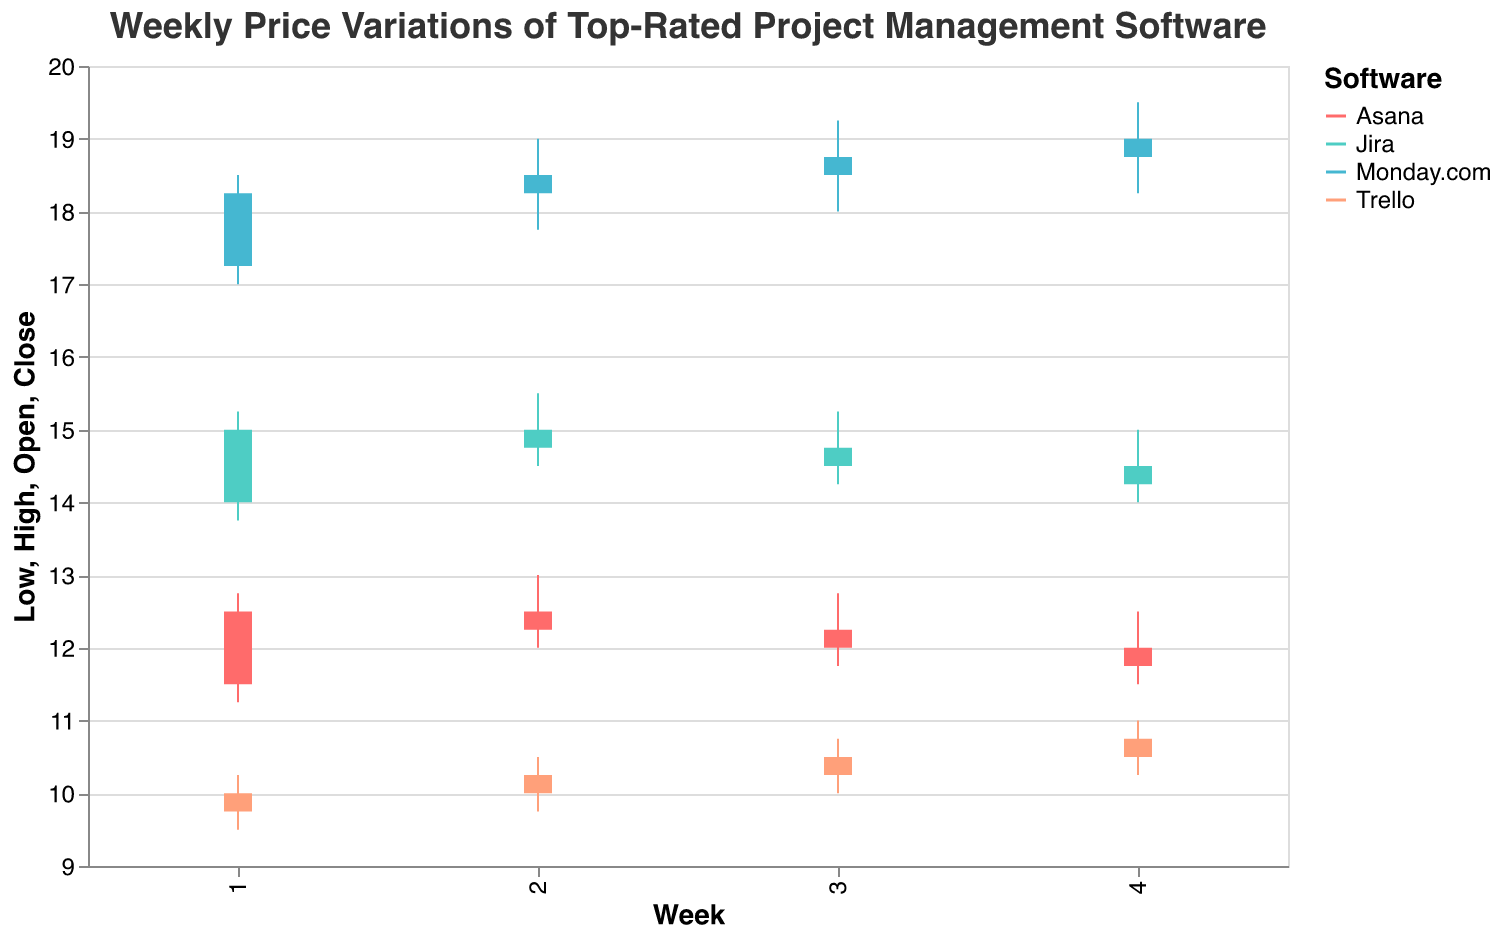What's the title of the OHLC chart? The title is usually displayed prominently at the top of the chart. In this case, the title clearly states the subject of the chart.
Answer: Weekly Price Variations of Top-Rated Project Management Software What color represents Trello in the chart? The legend in the chart indicates the color assigned to each software. Trello is represented by one of the unique colors listed.
Answer: #4ECDC4 Which software had the highest closing price in Week 1? Examine the closing prices for all software in Week 1 and identify the highest value.
Answer: Monday.com Did Asana's closing price increase or decrease over the weeks? Review the closing prices for Asana across Weeks 1 to 4 to observe the trend.
Answer: Decrease What is the average high price for Monday.com over the four weeks? Sum the high prices for Monday.com over Week 1 to Week 4 and then divide by 4 to get the average.
Answer: (18.50 + 19.00 + 19.25 + 19.50) / 4 = 19.06 In which week did Trello see the greatest range between its high and low prices? For each week, calculate the range (high - low) for Trello and determine which week has the greatest range.
Answer: Week 1 Compare the closing prices of Asana and Jira in Week 4. Which one is higher? Look at the closing prices of Asana and Jira in Week 4 and compare them to see which one is higher.
Answer: Asana What is the trend of Monday.com's closing prices over the four weeks? Observing the closing prices of Monday.com from Week 1 to Week 4, note if they are increasing, decreasing, or stable.
Answer: Increasing Which software had the smallest range between its high and low prices in Week 3? Calculate the range (high - low) for each software in Week 3 and identify the smallest range.
Answer: Jira Which software shows the most volatility in its high and low prices throughout the four weeks? For each software, examine the fluctuation of high and low prices over the four weeks and determine which has the most significant variation.
Answer: Asana 